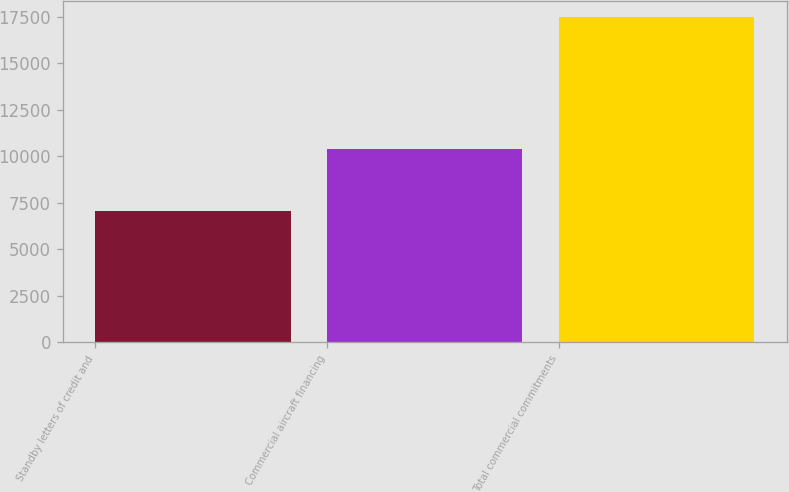<chart> <loc_0><loc_0><loc_500><loc_500><bar_chart><fcel>Standby letters of credit and<fcel>Commercial aircraft financing<fcel>Total commercial commitments<nl><fcel>7052<fcel>10409<fcel>17461<nl></chart> 